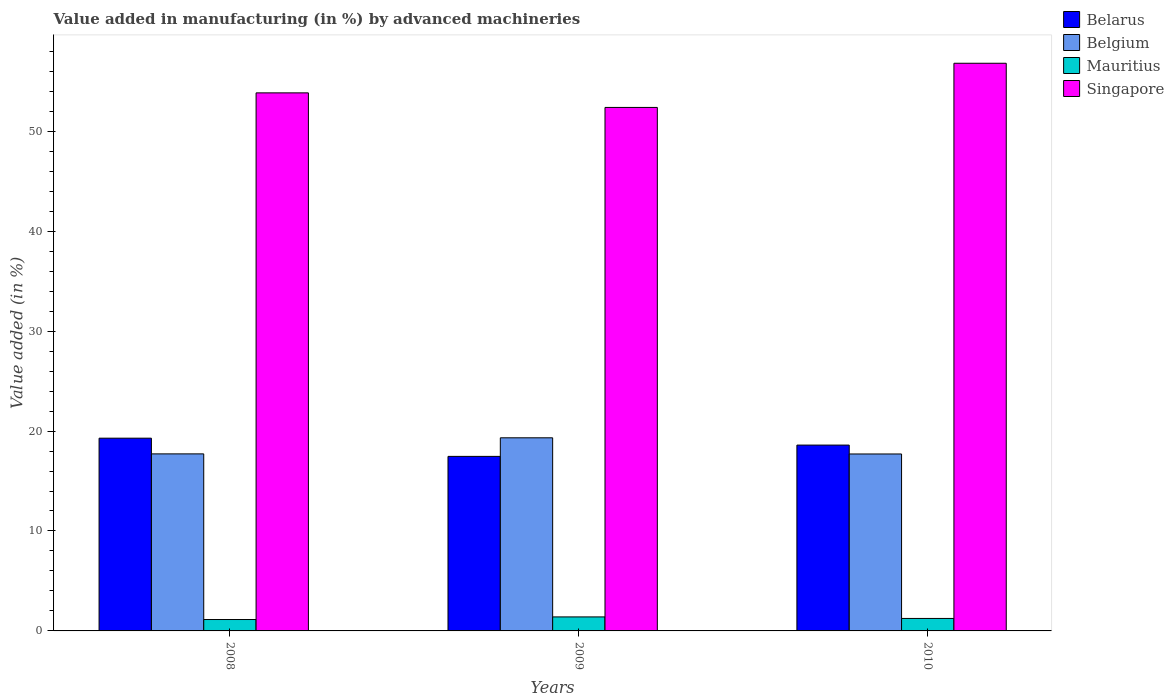Are the number of bars on each tick of the X-axis equal?
Ensure brevity in your answer.  Yes. How many bars are there on the 1st tick from the left?
Offer a very short reply. 4. What is the label of the 3rd group of bars from the left?
Offer a very short reply. 2010. What is the percentage of value added in manufacturing by advanced machineries in Mauritius in 2008?
Offer a very short reply. 1.14. Across all years, what is the maximum percentage of value added in manufacturing by advanced machineries in Belgium?
Offer a terse response. 19.32. Across all years, what is the minimum percentage of value added in manufacturing by advanced machineries in Singapore?
Ensure brevity in your answer.  52.38. In which year was the percentage of value added in manufacturing by advanced machineries in Belarus minimum?
Give a very brief answer. 2009. What is the total percentage of value added in manufacturing by advanced machineries in Singapore in the graph?
Offer a terse response. 163.02. What is the difference between the percentage of value added in manufacturing by advanced machineries in Belarus in 2008 and that in 2010?
Offer a very short reply. 0.69. What is the difference between the percentage of value added in manufacturing by advanced machineries in Singapore in 2010 and the percentage of value added in manufacturing by advanced machineries in Mauritius in 2009?
Keep it short and to the point. 55.4. What is the average percentage of value added in manufacturing by advanced machineries in Belgium per year?
Your answer should be very brief. 18.25. In the year 2009, what is the difference between the percentage of value added in manufacturing by advanced machineries in Belarus and percentage of value added in manufacturing by advanced machineries in Mauritius?
Offer a very short reply. 16.06. In how many years, is the percentage of value added in manufacturing by advanced machineries in Belarus greater than 26 %?
Provide a succinct answer. 0. What is the ratio of the percentage of value added in manufacturing by advanced machineries in Singapore in 2008 to that in 2009?
Provide a short and direct response. 1.03. Is the difference between the percentage of value added in manufacturing by advanced machineries in Belarus in 2008 and 2009 greater than the difference between the percentage of value added in manufacturing by advanced machineries in Mauritius in 2008 and 2009?
Offer a terse response. Yes. What is the difference between the highest and the second highest percentage of value added in manufacturing by advanced machineries in Belarus?
Make the answer very short. 0.69. What is the difference between the highest and the lowest percentage of value added in manufacturing by advanced machineries in Singapore?
Keep it short and to the point. 4.42. In how many years, is the percentage of value added in manufacturing by advanced machineries in Belgium greater than the average percentage of value added in manufacturing by advanced machineries in Belgium taken over all years?
Provide a short and direct response. 1. Is it the case that in every year, the sum of the percentage of value added in manufacturing by advanced machineries in Belarus and percentage of value added in manufacturing by advanced machineries in Singapore is greater than the sum of percentage of value added in manufacturing by advanced machineries in Belgium and percentage of value added in manufacturing by advanced machineries in Mauritius?
Your answer should be very brief. Yes. What does the 2nd bar from the left in 2008 represents?
Provide a short and direct response. Belgium. What does the 2nd bar from the right in 2009 represents?
Ensure brevity in your answer.  Mauritius. Is it the case that in every year, the sum of the percentage of value added in manufacturing by advanced machineries in Mauritius and percentage of value added in manufacturing by advanced machineries in Belarus is greater than the percentage of value added in manufacturing by advanced machineries in Belgium?
Provide a succinct answer. No. How many bars are there?
Provide a succinct answer. 12. What is the difference between two consecutive major ticks on the Y-axis?
Offer a very short reply. 10. Does the graph contain any zero values?
Offer a terse response. No. Does the graph contain grids?
Provide a short and direct response. No. How are the legend labels stacked?
Your answer should be very brief. Vertical. What is the title of the graph?
Offer a very short reply. Value added in manufacturing (in %) by advanced machineries. Does "Cameroon" appear as one of the legend labels in the graph?
Provide a short and direct response. No. What is the label or title of the X-axis?
Your answer should be compact. Years. What is the label or title of the Y-axis?
Keep it short and to the point. Value added (in %). What is the Value added (in %) of Belarus in 2008?
Provide a short and direct response. 19.29. What is the Value added (in %) of Belgium in 2008?
Your answer should be compact. 17.72. What is the Value added (in %) of Mauritius in 2008?
Provide a succinct answer. 1.14. What is the Value added (in %) of Singapore in 2008?
Provide a succinct answer. 53.84. What is the Value added (in %) of Belarus in 2009?
Offer a terse response. 17.46. What is the Value added (in %) of Belgium in 2009?
Make the answer very short. 19.32. What is the Value added (in %) in Mauritius in 2009?
Your response must be concise. 1.4. What is the Value added (in %) in Singapore in 2009?
Your response must be concise. 52.38. What is the Value added (in %) of Belarus in 2010?
Provide a succinct answer. 18.6. What is the Value added (in %) in Belgium in 2010?
Ensure brevity in your answer.  17.71. What is the Value added (in %) in Mauritius in 2010?
Provide a succinct answer. 1.25. What is the Value added (in %) in Singapore in 2010?
Your response must be concise. 56.8. Across all years, what is the maximum Value added (in %) of Belarus?
Offer a very short reply. 19.29. Across all years, what is the maximum Value added (in %) in Belgium?
Ensure brevity in your answer.  19.32. Across all years, what is the maximum Value added (in %) in Mauritius?
Ensure brevity in your answer.  1.4. Across all years, what is the maximum Value added (in %) in Singapore?
Your answer should be compact. 56.8. Across all years, what is the minimum Value added (in %) in Belarus?
Keep it short and to the point. 17.46. Across all years, what is the minimum Value added (in %) of Belgium?
Offer a terse response. 17.71. Across all years, what is the minimum Value added (in %) of Mauritius?
Keep it short and to the point. 1.14. Across all years, what is the minimum Value added (in %) in Singapore?
Give a very brief answer. 52.38. What is the total Value added (in %) of Belarus in the graph?
Your answer should be very brief. 55.35. What is the total Value added (in %) of Belgium in the graph?
Give a very brief answer. 54.74. What is the total Value added (in %) in Mauritius in the graph?
Keep it short and to the point. 3.79. What is the total Value added (in %) in Singapore in the graph?
Offer a very short reply. 163.02. What is the difference between the Value added (in %) in Belarus in 2008 and that in 2009?
Make the answer very short. 1.82. What is the difference between the Value added (in %) of Belgium in 2008 and that in 2009?
Provide a short and direct response. -1.61. What is the difference between the Value added (in %) in Mauritius in 2008 and that in 2009?
Provide a succinct answer. -0.26. What is the difference between the Value added (in %) of Singapore in 2008 and that in 2009?
Your answer should be very brief. 1.46. What is the difference between the Value added (in %) in Belarus in 2008 and that in 2010?
Your response must be concise. 0.69. What is the difference between the Value added (in %) in Belgium in 2008 and that in 2010?
Keep it short and to the point. 0.01. What is the difference between the Value added (in %) in Mauritius in 2008 and that in 2010?
Your answer should be very brief. -0.11. What is the difference between the Value added (in %) in Singapore in 2008 and that in 2010?
Provide a succinct answer. -2.96. What is the difference between the Value added (in %) of Belarus in 2009 and that in 2010?
Provide a short and direct response. -1.13. What is the difference between the Value added (in %) of Belgium in 2009 and that in 2010?
Give a very brief answer. 1.62. What is the difference between the Value added (in %) in Mauritius in 2009 and that in 2010?
Your answer should be compact. 0.15. What is the difference between the Value added (in %) of Singapore in 2009 and that in 2010?
Your answer should be very brief. -4.42. What is the difference between the Value added (in %) in Belarus in 2008 and the Value added (in %) in Belgium in 2009?
Make the answer very short. -0.04. What is the difference between the Value added (in %) in Belarus in 2008 and the Value added (in %) in Mauritius in 2009?
Ensure brevity in your answer.  17.88. What is the difference between the Value added (in %) in Belarus in 2008 and the Value added (in %) in Singapore in 2009?
Your answer should be compact. -33.1. What is the difference between the Value added (in %) in Belgium in 2008 and the Value added (in %) in Mauritius in 2009?
Your response must be concise. 16.31. What is the difference between the Value added (in %) of Belgium in 2008 and the Value added (in %) of Singapore in 2009?
Provide a short and direct response. -34.67. What is the difference between the Value added (in %) in Mauritius in 2008 and the Value added (in %) in Singapore in 2009?
Your response must be concise. -51.24. What is the difference between the Value added (in %) of Belarus in 2008 and the Value added (in %) of Belgium in 2010?
Make the answer very short. 1.58. What is the difference between the Value added (in %) in Belarus in 2008 and the Value added (in %) in Mauritius in 2010?
Keep it short and to the point. 18.04. What is the difference between the Value added (in %) of Belarus in 2008 and the Value added (in %) of Singapore in 2010?
Ensure brevity in your answer.  -37.52. What is the difference between the Value added (in %) in Belgium in 2008 and the Value added (in %) in Mauritius in 2010?
Offer a very short reply. 16.47. What is the difference between the Value added (in %) of Belgium in 2008 and the Value added (in %) of Singapore in 2010?
Offer a terse response. -39.09. What is the difference between the Value added (in %) of Mauritius in 2008 and the Value added (in %) of Singapore in 2010?
Provide a succinct answer. -55.66. What is the difference between the Value added (in %) in Belarus in 2009 and the Value added (in %) in Belgium in 2010?
Give a very brief answer. -0.24. What is the difference between the Value added (in %) in Belarus in 2009 and the Value added (in %) in Mauritius in 2010?
Your answer should be very brief. 16.22. What is the difference between the Value added (in %) of Belarus in 2009 and the Value added (in %) of Singapore in 2010?
Ensure brevity in your answer.  -39.34. What is the difference between the Value added (in %) in Belgium in 2009 and the Value added (in %) in Mauritius in 2010?
Ensure brevity in your answer.  18.08. What is the difference between the Value added (in %) of Belgium in 2009 and the Value added (in %) of Singapore in 2010?
Your answer should be very brief. -37.48. What is the difference between the Value added (in %) of Mauritius in 2009 and the Value added (in %) of Singapore in 2010?
Your response must be concise. -55.4. What is the average Value added (in %) in Belarus per year?
Your answer should be compact. 18.45. What is the average Value added (in %) in Belgium per year?
Provide a short and direct response. 18.25. What is the average Value added (in %) of Mauritius per year?
Ensure brevity in your answer.  1.26. What is the average Value added (in %) of Singapore per year?
Your response must be concise. 54.34. In the year 2008, what is the difference between the Value added (in %) in Belarus and Value added (in %) in Belgium?
Give a very brief answer. 1.57. In the year 2008, what is the difference between the Value added (in %) in Belarus and Value added (in %) in Mauritius?
Give a very brief answer. 18.15. In the year 2008, what is the difference between the Value added (in %) of Belarus and Value added (in %) of Singapore?
Keep it short and to the point. -34.55. In the year 2008, what is the difference between the Value added (in %) of Belgium and Value added (in %) of Mauritius?
Offer a very short reply. 16.58. In the year 2008, what is the difference between the Value added (in %) in Belgium and Value added (in %) in Singapore?
Provide a short and direct response. -36.12. In the year 2008, what is the difference between the Value added (in %) in Mauritius and Value added (in %) in Singapore?
Your answer should be very brief. -52.7. In the year 2009, what is the difference between the Value added (in %) in Belarus and Value added (in %) in Belgium?
Provide a succinct answer. -1.86. In the year 2009, what is the difference between the Value added (in %) in Belarus and Value added (in %) in Mauritius?
Make the answer very short. 16.06. In the year 2009, what is the difference between the Value added (in %) of Belarus and Value added (in %) of Singapore?
Your answer should be compact. -34.92. In the year 2009, what is the difference between the Value added (in %) of Belgium and Value added (in %) of Mauritius?
Your answer should be compact. 17.92. In the year 2009, what is the difference between the Value added (in %) in Belgium and Value added (in %) in Singapore?
Your answer should be very brief. -33.06. In the year 2009, what is the difference between the Value added (in %) in Mauritius and Value added (in %) in Singapore?
Your response must be concise. -50.98. In the year 2010, what is the difference between the Value added (in %) of Belarus and Value added (in %) of Belgium?
Ensure brevity in your answer.  0.89. In the year 2010, what is the difference between the Value added (in %) of Belarus and Value added (in %) of Mauritius?
Give a very brief answer. 17.35. In the year 2010, what is the difference between the Value added (in %) in Belarus and Value added (in %) in Singapore?
Keep it short and to the point. -38.21. In the year 2010, what is the difference between the Value added (in %) in Belgium and Value added (in %) in Mauritius?
Keep it short and to the point. 16.46. In the year 2010, what is the difference between the Value added (in %) of Belgium and Value added (in %) of Singapore?
Provide a succinct answer. -39.1. In the year 2010, what is the difference between the Value added (in %) in Mauritius and Value added (in %) in Singapore?
Give a very brief answer. -55.55. What is the ratio of the Value added (in %) of Belarus in 2008 to that in 2009?
Ensure brevity in your answer.  1.1. What is the ratio of the Value added (in %) in Belgium in 2008 to that in 2009?
Provide a succinct answer. 0.92. What is the ratio of the Value added (in %) of Mauritius in 2008 to that in 2009?
Your answer should be very brief. 0.81. What is the ratio of the Value added (in %) of Singapore in 2008 to that in 2009?
Offer a very short reply. 1.03. What is the ratio of the Value added (in %) in Belarus in 2008 to that in 2010?
Your answer should be very brief. 1.04. What is the ratio of the Value added (in %) of Belgium in 2008 to that in 2010?
Your response must be concise. 1. What is the ratio of the Value added (in %) in Mauritius in 2008 to that in 2010?
Make the answer very short. 0.91. What is the ratio of the Value added (in %) in Singapore in 2008 to that in 2010?
Make the answer very short. 0.95. What is the ratio of the Value added (in %) of Belarus in 2009 to that in 2010?
Keep it short and to the point. 0.94. What is the ratio of the Value added (in %) of Belgium in 2009 to that in 2010?
Make the answer very short. 1.09. What is the ratio of the Value added (in %) of Mauritius in 2009 to that in 2010?
Ensure brevity in your answer.  1.12. What is the ratio of the Value added (in %) of Singapore in 2009 to that in 2010?
Provide a short and direct response. 0.92. What is the difference between the highest and the second highest Value added (in %) in Belarus?
Keep it short and to the point. 0.69. What is the difference between the highest and the second highest Value added (in %) in Belgium?
Make the answer very short. 1.61. What is the difference between the highest and the second highest Value added (in %) in Mauritius?
Your answer should be very brief. 0.15. What is the difference between the highest and the second highest Value added (in %) in Singapore?
Provide a short and direct response. 2.96. What is the difference between the highest and the lowest Value added (in %) of Belarus?
Your answer should be very brief. 1.82. What is the difference between the highest and the lowest Value added (in %) in Belgium?
Give a very brief answer. 1.62. What is the difference between the highest and the lowest Value added (in %) of Mauritius?
Your answer should be very brief. 0.26. What is the difference between the highest and the lowest Value added (in %) in Singapore?
Your answer should be very brief. 4.42. 